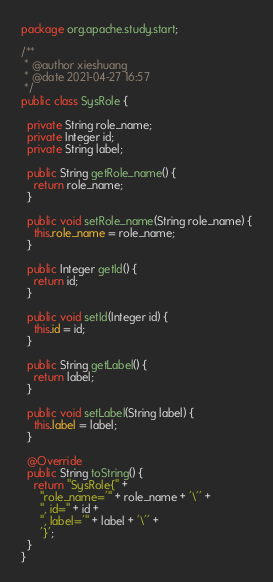Convert code to text. <code><loc_0><loc_0><loc_500><loc_500><_Java_>package org.apache.study.start;

/**
 * @author xieshuang
 * @date 2021-04-27 16:57
 */
public class SysRole {

  private String role_name;
  private Integer id;
  private String label;

  public String getRole_name() {
    return role_name;
  }

  public void setRole_name(String role_name) {
    this.role_name = role_name;
  }

  public Integer getId() {
    return id;
  }

  public void setId(Integer id) {
    this.id = id;
  }

  public String getLabel() {
    return label;
  }

  public void setLabel(String label) {
    this.label = label;
  }

  @Override
  public String toString() {
    return "SysRole{" +
      "role_name='" + role_name + '\'' +
      ", id=" + id +
      ", label='" + label + '\'' +
      '}';
  }
}
</code> 